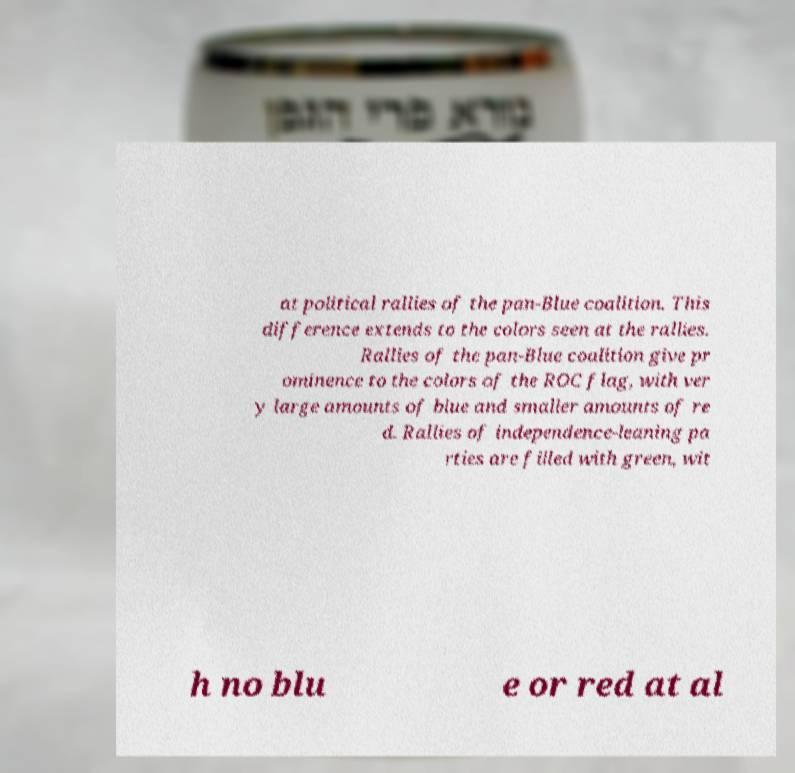Could you assist in decoding the text presented in this image and type it out clearly? at political rallies of the pan-Blue coalition. This difference extends to the colors seen at the rallies. Rallies of the pan-Blue coalition give pr ominence to the colors of the ROC flag, with ver y large amounts of blue and smaller amounts of re d. Rallies of independence-leaning pa rties are filled with green, wit h no blu e or red at al 